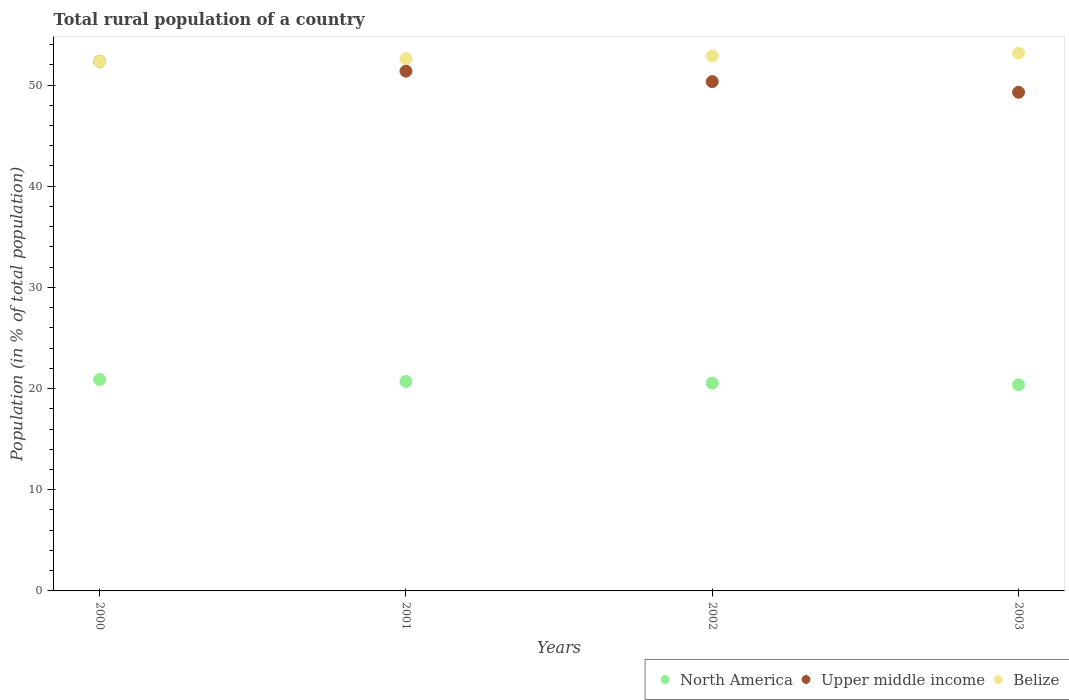Is the number of dotlines equal to the number of legend labels?
Ensure brevity in your answer.  Yes. What is the rural population in North America in 2002?
Your answer should be compact. 20.54. Across all years, what is the maximum rural population in North America?
Provide a short and direct response. 20.9. Across all years, what is the minimum rural population in Upper middle income?
Offer a very short reply. 49.28. In which year was the rural population in North America minimum?
Provide a short and direct response. 2003. What is the total rural population in Belize in the graph?
Provide a short and direct response. 210.97. What is the difference between the rural population in Upper middle income in 2000 and that in 2003?
Your answer should be compact. 3.06. What is the difference between the rural population in Belize in 2002 and the rural population in North America in 2003?
Give a very brief answer. 32.5. What is the average rural population in Belize per year?
Give a very brief answer. 52.74. In the year 2000, what is the difference between the rural population in Belize and rural population in North America?
Offer a terse response. 31.44. In how many years, is the rural population in North America greater than 36 %?
Make the answer very short. 0. What is the ratio of the rural population in Belize in 2000 to that in 2003?
Provide a succinct answer. 0.98. Is the difference between the rural population in Belize in 2002 and 2003 greater than the difference between the rural population in North America in 2002 and 2003?
Your answer should be compact. No. What is the difference between the highest and the second highest rural population in Belize?
Provide a short and direct response. 0.27. What is the difference between the highest and the lowest rural population in Belize?
Your answer should be compact. 0.81. Is the rural population in North America strictly greater than the rural population in Upper middle income over the years?
Keep it short and to the point. No. How many dotlines are there?
Your answer should be compact. 3. How many years are there in the graph?
Give a very brief answer. 4. Are the values on the major ticks of Y-axis written in scientific E-notation?
Give a very brief answer. No. Does the graph contain any zero values?
Your answer should be very brief. No. What is the title of the graph?
Your response must be concise. Total rural population of a country. What is the label or title of the X-axis?
Offer a terse response. Years. What is the label or title of the Y-axis?
Give a very brief answer. Population (in % of total population). What is the Population (in % of total population) in North America in 2000?
Ensure brevity in your answer.  20.9. What is the Population (in % of total population) in Upper middle income in 2000?
Your answer should be compact. 52.34. What is the Population (in % of total population) of Belize in 2000?
Provide a short and direct response. 52.34. What is the Population (in % of total population) of North America in 2001?
Ensure brevity in your answer.  20.71. What is the Population (in % of total population) in Upper middle income in 2001?
Offer a very short reply. 51.37. What is the Population (in % of total population) in Belize in 2001?
Your answer should be very brief. 52.61. What is the Population (in % of total population) in North America in 2002?
Keep it short and to the point. 20.54. What is the Population (in % of total population) in Upper middle income in 2002?
Offer a terse response. 50.33. What is the Population (in % of total population) of Belize in 2002?
Offer a very short reply. 52.88. What is the Population (in % of total population) of North America in 2003?
Provide a succinct answer. 20.38. What is the Population (in % of total population) of Upper middle income in 2003?
Offer a very short reply. 49.28. What is the Population (in % of total population) in Belize in 2003?
Ensure brevity in your answer.  53.15. Across all years, what is the maximum Population (in % of total population) of North America?
Offer a terse response. 20.9. Across all years, what is the maximum Population (in % of total population) of Upper middle income?
Provide a succinct answer. 52.34. Across all years, what is the maximum Population (in % of total population) of Belize?
Your answer should be very brief. 53.15. Across all years, what is the minimum Population (in % of total population) of North America?
Provide a short and direct response. 20.38. Across all years, what is the minimum Population (in % of total population) of Upper middle income?
Offer a terse response. 49.28. Across all years, what is the minimum Population (in % of total population) in Belize?
Your answer should be very brief. 52.34. What is the total Population (in % of total population) in North America in the graph?
Offer a terse response. 82.52. What is the total Population (in % of total population) of Upper middle income in the graph?
Offer a very short reply. 203.33. What is the total Population (in % of total population) of Belize in the graph?
Keep it short and to the point. 210.97. What is the difference between the Population (in % of total population) in North America in 2000 and that in 2001?
Keep it short and to the point. 0.19. What is the difference between the Population (in % of total population) in Upper middle income in 2000 and that in 2001?
Your answer should be very brief. 0.97. What is the difference between the Population (in % of total population) of Belize in 2000 and that in 2001?
Offer a very short reply. -0.27. What is the difference between the Population (in % of total population) of North America in 2000 and that in 2002?
Give a very brief answer. 0.36. What is the difference between the Population (in % of total population) in Upper middle income in 2000 and that in 2002?
Keep it short and to the point. 2.01. What is the difference between the Population (in % of total population) of Belize in 2000 and that in 2002?
Keep it short and to the point. -0.54. What is the difference between the Population (in % of total population) in North America in 2000 and that in 2003?
Offer a terse response. 0.52. What is the difference between the Population (in % of total population) of Upper middle income in 2000 and that in 2003?
Ensure brevity in your answer.  3.06. What is the difference between the Population (in % of total population) of Belize in 2000 and that in 2003?
Provide a succinct answer. -0.81. What is the difference between the Population (in % of total population) in North America in 2001 and that in 2002?
Provide a succinct answer. 0.17. What is the difference between the Population (in % of total population) of Upper middle income in 2001 and that in 2002?
Provide a short and direct response. 1.04. What is the difference between the Population (in % of total population) in Belize in 2001 and that in 2002?
Your response must be concise. -0.27. What is the difference between the Population (in % of total population) of North America in 2001 and that in 2003?
Provide a succinct answer. 0.33. What is the difference between the Population (in % of total population) of Upper middle income in 2001 and that in 2003?
Your answer should be compact. 2.09. What is the difference between the Population (in % of total population) of Belize in 2001 and that in 2003?
Your answer should be very brief. -0.54. What is the difference between the Population (in % of total population) of North America in 2002 and that in 2003?
Offer a terse response. 0.16. What is the difference between the Population (in % of total population) of Upper middle income in 2002 and that in 2003?
Your answer should be compact. 1.05. What is the difference between the Population (in % of total population) of Belize in 2002 and that in 2003?
Offer a very short reply. -0.27. What is the difference between the Population (in % of total population) of North America in 2000 and the Population (in % of total population) of Upper middle income in 2001?
Provide a short and direct response. -30.47. What is the difference between the Population (in % of total population) in North America in 2000 and the Population (in % of total population) in Belize in 2001?
Provide a succinct answer. -31.71. What is the difference between the Population (in % of total population) in Upper middle income in 2000 and the Population (in % of total population) in Belize in 2001?
Keep it short and to the point. -0.27. What is the difference between the Population (in % of total population) of North America in 2000 and the Population (in % of total population) of Upper middle income in 2002?
Offer a very short reply. -29.44. What is the difference between the Population (in % of total population) in North America in 2000 and the Population (in % of total population) in Belize in 2002?
Provide a short and direct response. -31.98. What is the difference between the Population (in % of total population) of Upper middle income in 2000 and the Population (in % of total population) of Belize in 2002?
Your answer should be very brief. -0.54. What is the difference between the Population (in % of total population) of North America in 2000 and the Population (in % of total population) of Upper middle income in 2003?
Keep it short and to the point. -28.39. What is the difference between the Population (in % of total population) in North America in 2000 and the Population (in % of total population) in Belize in 2003?
Your response must be concise. -32.25. What is the difference between the Population (in % of total population) of Upper middle income in 2000 and the Population (in % of total population) of Belize in 2003?
Your answer should be compact. -0.81. What is the difference between the Population (in % of total population) in North America in 2001 and the Population (in % of total population) in Upper middle income in 2002?
Provide a succinct answer. -29.63. What is the difference between the Population (in % of total population) in North America in 2001 and the Population (in % of total population) in Belize in 2002?
Your answer should be very brief. -32.17. What is the difference between the Population (in % of total population) in Upper middle income in 2001 and the Population (in % of total population) in Belize in 2002?
Offer a very short reply. -1.51. What is the difference between the Population (in % of total population) in North America in 2001 and the Population (in % of total population) in Upper middle income in 2003?
Make the answer very short. -28.58. What is the difference between the Population (in % of total population) of North America in 2001 and the Population (in % of total population) of Belize in 2003?
Ensure brevity in your answer.  -32.44. What is the difference between the Population (in % of total population) in Upper middle income in 2001 and the Population (in % of total population) in Belize in 2003?
Your response must be concise. -1.78. What is the difference between the Population (in % of total population) in North America in 2002 and the Population (in % of total population) in Upper middle income in 2003?
Your response must be concise. -28.74. What is the difference between the Population (in % of total population) in North America in 2002 and the Population (in % of total population) in Belize in 2003?
Make the answer very short. -32.61. What is the difference between the Population (in % of total population) of Upper middle income in 2002 and the Population (in % of total population) of Belize in 2003?
Your answer should be compact. -2.82. What is the average Population (in % of total population) in North America per year?
Provide a short and direct response. 20.63. What is the average Population (in % of total population) of Upper middle income per year?
Give a very brief answer. 50.83. What is the average Population (in % of total population) in Belize per year?
Provide a succinct answer. 52.74. In the year 2000, what is the difference between the Population (in % of total population) in North America and Population (in % of total population) in Upper middle income?
Offer a terse response. -31.44. In the year 2000, what is the difference between the Population (in % of total population) of North America and Population (in % of total population) of Belize?
Make the answer very short. -31.44. In the year 2000, what is the difference between the Population (in % of total population) of Upper middle income and Population (in % of total population) of Belize?
Give a very brief answer. 0.01. In the year 2001, what is the difference between the Population (in % of total population) in North America and Population (in % of total population) in Upper middle income?
Your response must be concise. -30.67. In the year 2001, what is the difference between the Population (in % of total population) in North America and Population (in % of total population) in Belize?
Your response must be concise. -31.9. In the year 2001, what is the difference between the Population (in % of total population) of Upper middle income and Population (in % of total population) of Belize?
Make the answer very short. -1.24. In the year 2002, what is the difference between the Population (in % of total population) of North America and Population (in % of total population) of Upper middle income?
Provide a succinct answer. -29.79. In the year 2002, what is the difference between the Population (in % of total population) of North America and Population (in % of total population) of Belize?
Offer a terse response. -32.34. In the year 2002, what is the difference between the Population (in % of total population) in Upper middle income and Population (in % of total population) in Belize?
Your response must be concise. -2.54. In the year 2003, what is the difference between the Population (in % of total population) in North America and Population (in % of total population) in Upper middle income?
Make the answer very short. -28.91. In the year 2003, what is the difference between the Population (in % of total population) of North America and Population (in % of total population) of Belize?
Offer a very short reply. -32.77. In the year 2003, what is the difference between the Population (in % of total population) in Upper middle income and Population (in % of total population) in Belize?
Give a very brief answer. -3.87. What is the ratio of the Population (in % of total population) in North America in 2000 to that in 2001?
Offer a very short reply. 1.01. What is the ratio of the Population (in % of total population) of Upper middle income in 2000 to that in 2001?
Give a very brief answer. 1.02. What is the ratio of the Population (in % of total population) in Belize in 2000 to that in 2001?
Ensure brevity in your answer.  0.99. What is the ratio of the Population (in % of total population) of North America in 2000 to that in 2002?
Offer a terse response. 1.02. What is the ratio of the Population (in % of total population) of Upper middle income in 2000 to that in 2002?
Give a very brief answer. 1.04. What is the ratio of the Population (in % of total population) of North America in 2000 to that in 2003?
Provide a short and direct response. 1.03. What is the ratio of the Population (in % of total population) in Upper middle income in 2000 to that in 2003?
Give a very brief answer. 1.06. What is the ratio of the Population (in % of total population) in Belize in 2000 to that in 2003?
Your response must be concise. 0.98. What is the ratio of the Population (in % of total population) in North America in 2001 to that in 2002?
Ensure brevity in your answer.  1.01. What is the ratio of the Population (in % of total population) of Upper middle income in 2001 to that in 2002?
Provide a short and direct response. 1.02. What is the ratio of the Population (in % of total population) of Belize in 2001 to that in 2002?
Provide a short and direct response. 0.99. What is the ratio of the Population (in % of total population) of North America in 2001 to that in 2003?
Your answer should be very brief. 1.02. What is the ratio of the Population (in % of total population) of Upper middle income in 2001 to that in 2003?
Provide a succinct answer. 1.04. What is the ratio of the Population (in % of total population) in Upper middle income in 2002 to that in 2003?
Keep it short and to the point. 1.02. What is the difference between the highest and the second highest Population (in % of total population) in North America?
Your response must be concise. 0.19. What is the difference between the highest and the second highest Population (in % of total population) in Upper middle income?
Provide a succinct answer. 0.97. What is the difference between the highest and the second highest Population (in % of total population) of Belize?
Offer a terse response. 0.27. What is the difference between the highest and the lowest Population (in % of total population) of North America?
Give a very brief answer. 0.52. What is the difference between the highest and the lowest Population (in % of total population) in Upper middle income?
Your response must be concise. 3.06. What is the difference between the highest and the lowest Population (in % of total population) in Belize?
Your answer should be compact. 0.81. 